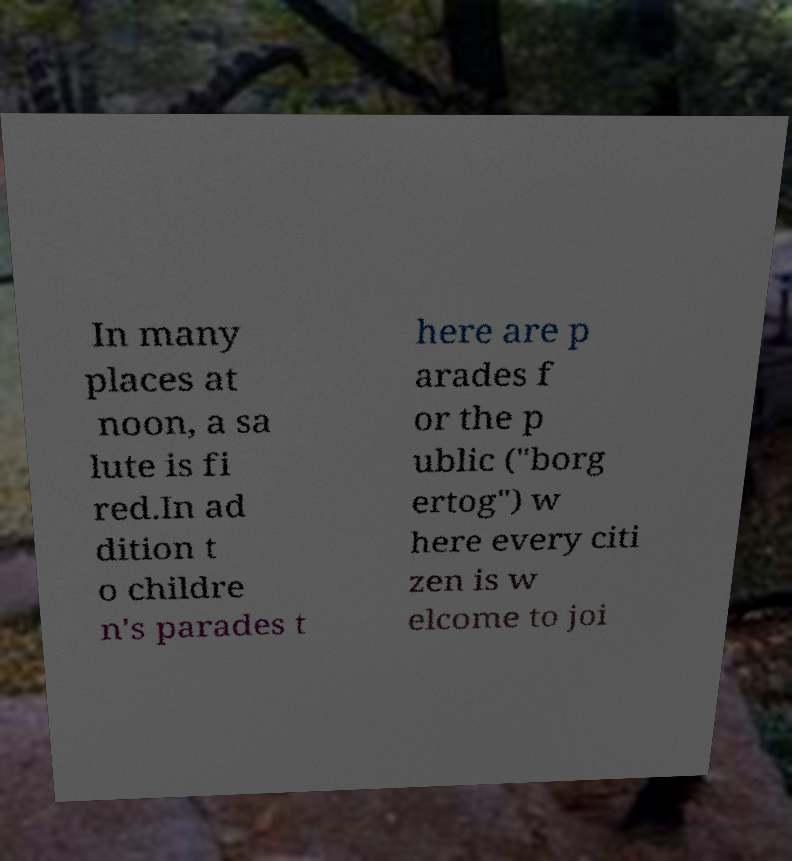Could you extract and type out the text from this image? In many places at noon, a sa lute is fi red.In ad dition t o childre n's parades t here are p arades f or the p ublic ("borg ertog") w here every citi zen is w elcome to joi 